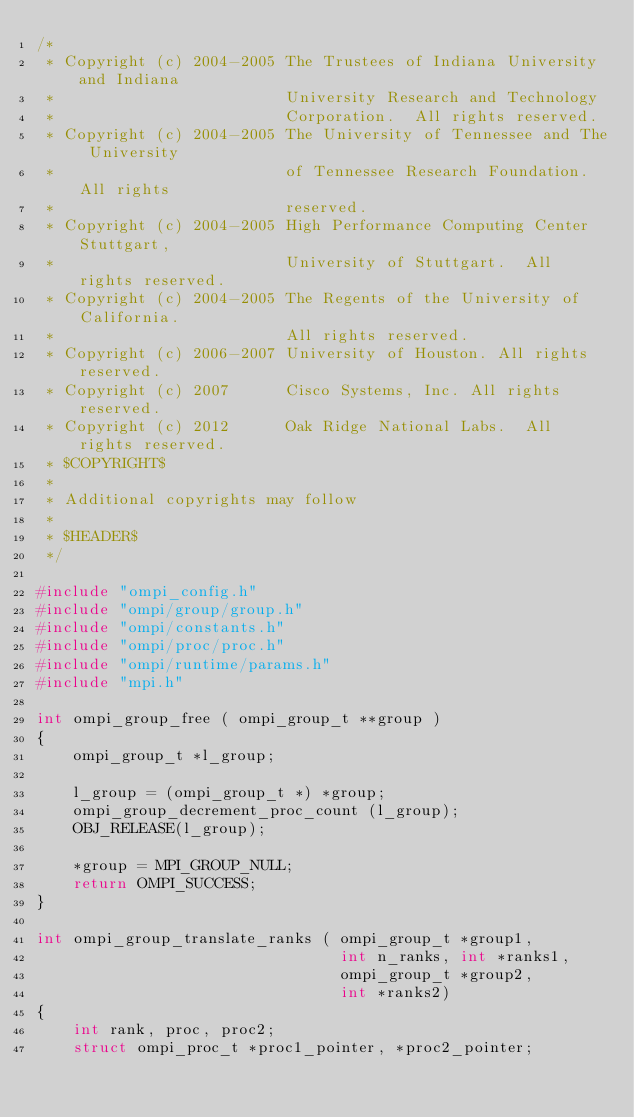Convert code to text. <code><loc_0><loc_0><loc_500><loc_500><_C_>/* 
 * Copyright (c) 2004-2005 The Trustees of Indiana University and Indiana
 *                         University Research and Technology
 *                         Corporation.  All rights reserved.
 * Copyright (c) 2004-2005 The University of Tennessee and The University
 *                         of Tennessee Research Foundation.  All rights
 *                         reserved.
 * Copyright (c) 2004-2005 High Performance Computing Center Stuttgart, 
 *                         University of Stuttgart.  All rights reserved.
 * Copyright (c) 2004-2005 The Regents of the University of California.
 *                         All rights reserved.
 * Copyright (c) 2006-2007 University of Houston. All rights reserved.
 * Copyright (c) 2007      Cisco Systems, Inc. All rights reserved.
 * Copyright (c) 2012      Oak Ridge National Labs.  All rights reserved.
 * $COPYRIGHT$
 * 
 * Additional copyrights may follow
 * 
 * $HEADER$
 */

#include "ompi_config.h"
#include "ompi/group/group.h"
#include "ompi/constants.h"
#include "ompi/proc/proc.h"
#include "ompi/runtime/params.h"
#include "mpi.h"

int ompi_group_free ( ompi_group_t **group )
{
    ompi_group_t *l_group;

    l_group = (ompi_group_t *) *group;
    ompi_group_decrement_proc_count (l_group);
    OBJ_RELEASE(l_group);

    *group = MPI_GROUP_NULL;
    return OMPI_SUCCESS;
}

int ompi_group_translate_ranks ( ompi_group_t *group1, 
                                 int n_ranks, int *ranks1,
                                 ompi_group_t *group2, 
                                 int *ranks2) 
{
    int rank, proc, proc2;
    struct ompi_proc_t *proc1_pointer, *proc2_pointer;
</code> 